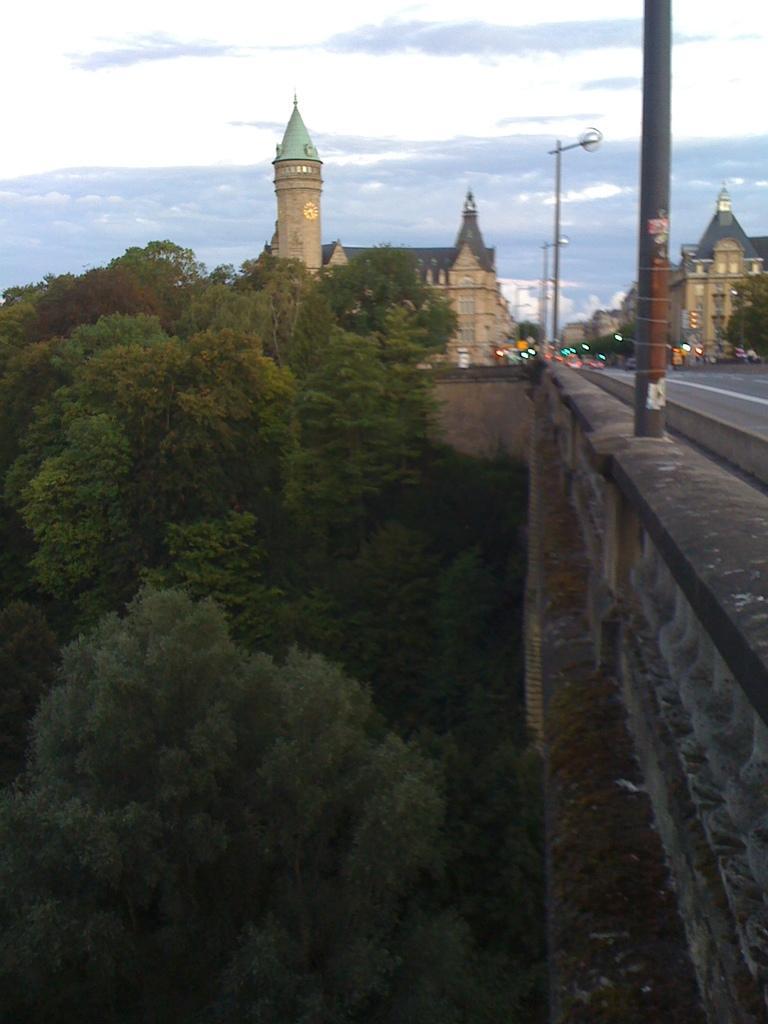Can you describe this image briefly? In this picture I can see the church, buildings, road and street lights. On the right there is a bridge and wall. On the left I can see many trees. In the background I can see some vehicles near to the traffic signals and poles. At the top I can see sky and clouds. 